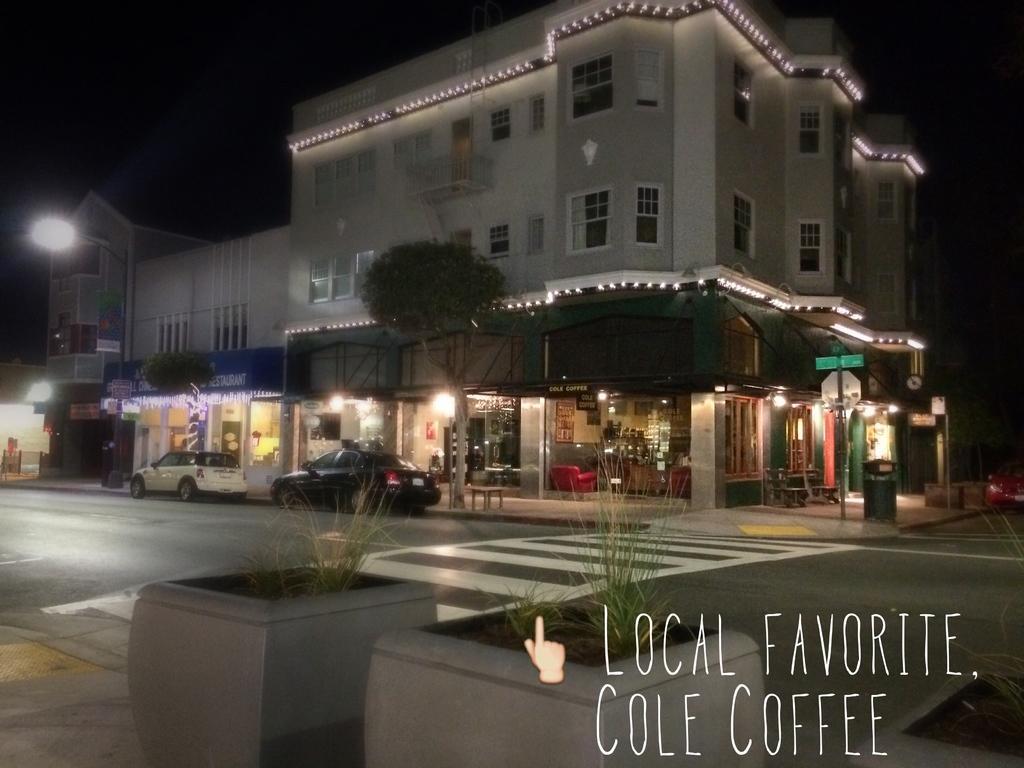Describe this image in one or two sentences. In this picture, we can see a few buildings with lights, windows, posters, and we can see stores, poles, lights, sign boards, vehicles and plants, and we can see some text in the bottom right corner. 